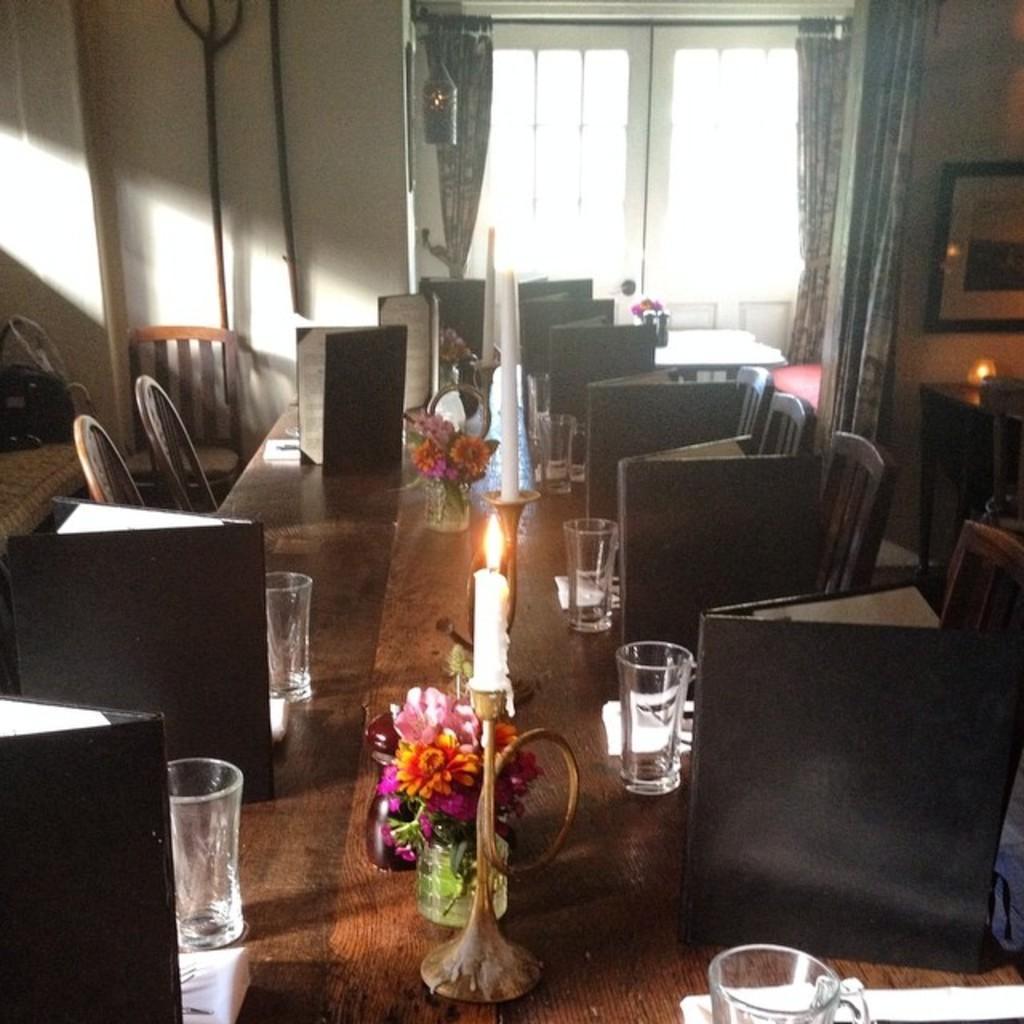Describe this image in one or two sentences. In this image, I can see a wooden table with flower vases, glasses, menu cards, candles with candle stands and few other things. On the left and right side of the image, I can see the chairs. In the background, there is a window with doors and curtains hanging to a hanger. On the right side of the image, I can see a photo frame attached to a wall. 